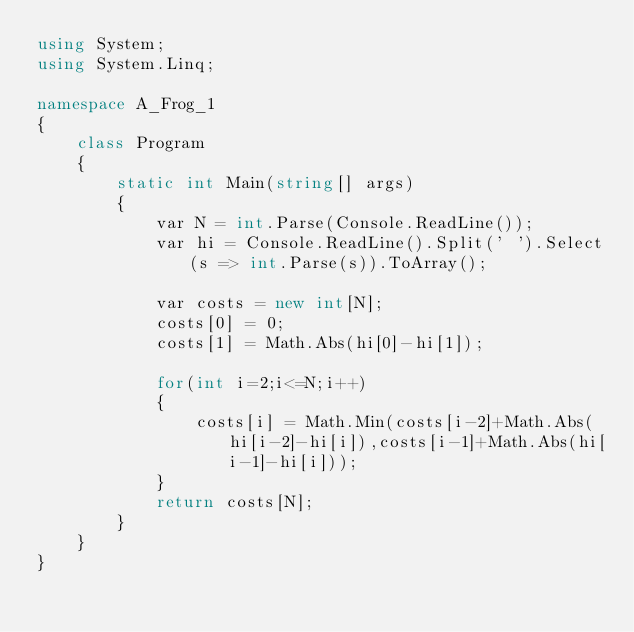<code> <loc_0><loc_0><loc_500><loc_500><_C#_>using System;
using System.Linq;

namespace A_Frog_1
{
    class Program
    {
        static int Main(string[] args)
        {
            var N = int.Parse(Console.ReadLine());
            var hi = Console.ReadLine().Split(' ').Select(s => int.Parse(s)).ToArray();

            var costs = new int[N];
            costs[0] = 0;
            costs[1] = Math.Abs(hi[0]-hi[1]);

            for(int i=2;i<=N;i++)
            {
                costs[i] = Math.Min(costs[i-2]+Math.Abs(hi[i-2]-hi[i]),costs[i-1]+Math.Abs(hi[i-1]-hi[i]));
            }
            return costs[N];
        }
    }
}</code> 